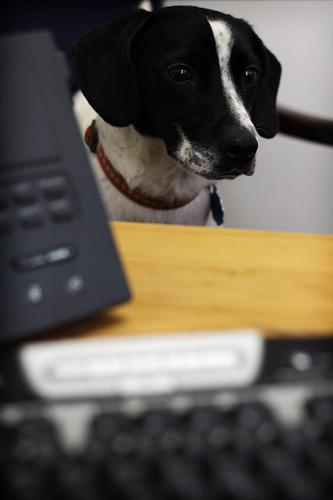Question: why does the dog wear the metal object?
Choices:
A. Shock collar for control.
B. To trip magnetic alarm.
C. Cruel owner.
D. For identification.
Answer with the letter. Answer: D Question: where are the electronics?
Choices:
A. Inside the phone.
B. Under the hood.
C. A desk.
D. Best Buy.
Answer with the letter. Answer: C Question: who would provide medical care for the being in the photo?
Choices:
A. Nurse.
B. Vet Tech.
C. Doctor.
D. Veterinarian.
Answer with the letter. Answer: D Question: what animal is this?
Choices:
A. A cow.
B. A giraffe.
C. A horse.
D. A dog.
Answer with the letter. Answer: D Question: how many dogs are there?
Choices:
A. Two.
B. Three.
C. Four.
D. One.
Answer with the letter. Answer: D Question: where is the table?
Choices:
A. By the window.
B. By the couch.
C. By the door.
D. In front of the dog.
Answer with the letter. Answer: D Question: what color is the dog?
Choices:
A. Brown and white.
B. White and grey.
C. Grey and brown.
D. Black and white.
Answer with the letter. Answer: D Question: what is on the dog's neck?
Choices:
A. A tick.
B. A collar with a tag.
C. Hair.
D. A leash.
Answer with the letter. Answer: B 